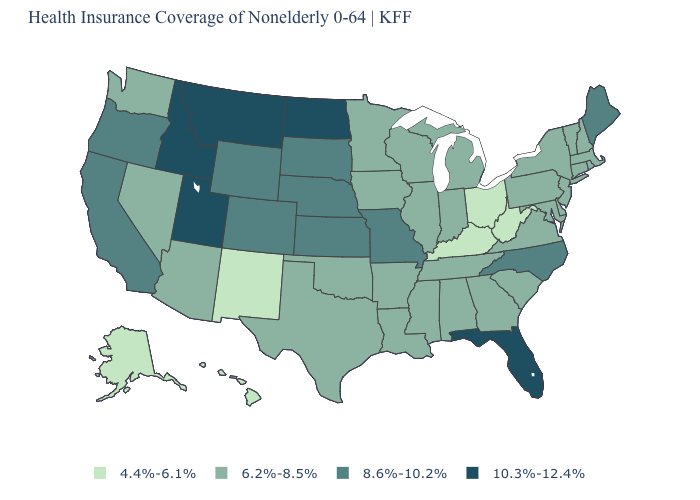Which states have the lowest value in the South?
Concise answer only. Kentucky, West Virginia. What is the value of Nebraska?
Concise answer only. 8.6%-10.2%. What is the lowest value in the USA?
Concise answer only. 4.4%-6.1%. Is the legend a continuous bar?
Be succinct. No. Name the states that have a value in the range 6.2%-8.5%?
Be succinct. Alabama, Arizona, Arkansas, Connecticut, Delaware, Georgia, Illinois, Indiana, Iowa, Louisiana, Maryland, Massachusetts, Michigan, Minnesota, Mississippi, Nevada, New Hampshire, New Jersey, New York, Oklahoma, Pennsylvania, Rhode Island, South Carolina, Tennessee, Texas, Vermont, Virginia, Washington, Wisconsin. Does Minnesota have a higher value than Alabama?
Give a very brief answer. No. What is the value of West Virginia?
Give a very brief answer. 4.4%-6.1%. Name the states that have a value in the range 4.4%-6.1%?
Write a very short answer. Alaska, Hawaii, Kentucky, New Mexico, Ohio, West Virginia. What is the value of West Virginia?
Quick response, please. 4.4%-6.1%. How many symbols are there in the legend?
Answer briefly. 4. Is the legend a continuous bar?
Short answer required. No. Among the states that border Oklahoma , which have the lowest value?
Quick response, please. New Mexico. Name the states that have a value in the range 4.4%-6.1%?
Be succinct. Alaska, Hawaii, Kentucky, New Mexico, Ohio, West Virginia. Name the states that have a value in the range 4.4%-6.1%?
Be succinct. Alaska, Hawaii, Kentucky, New Mexico, Ohio, West Virginia. 